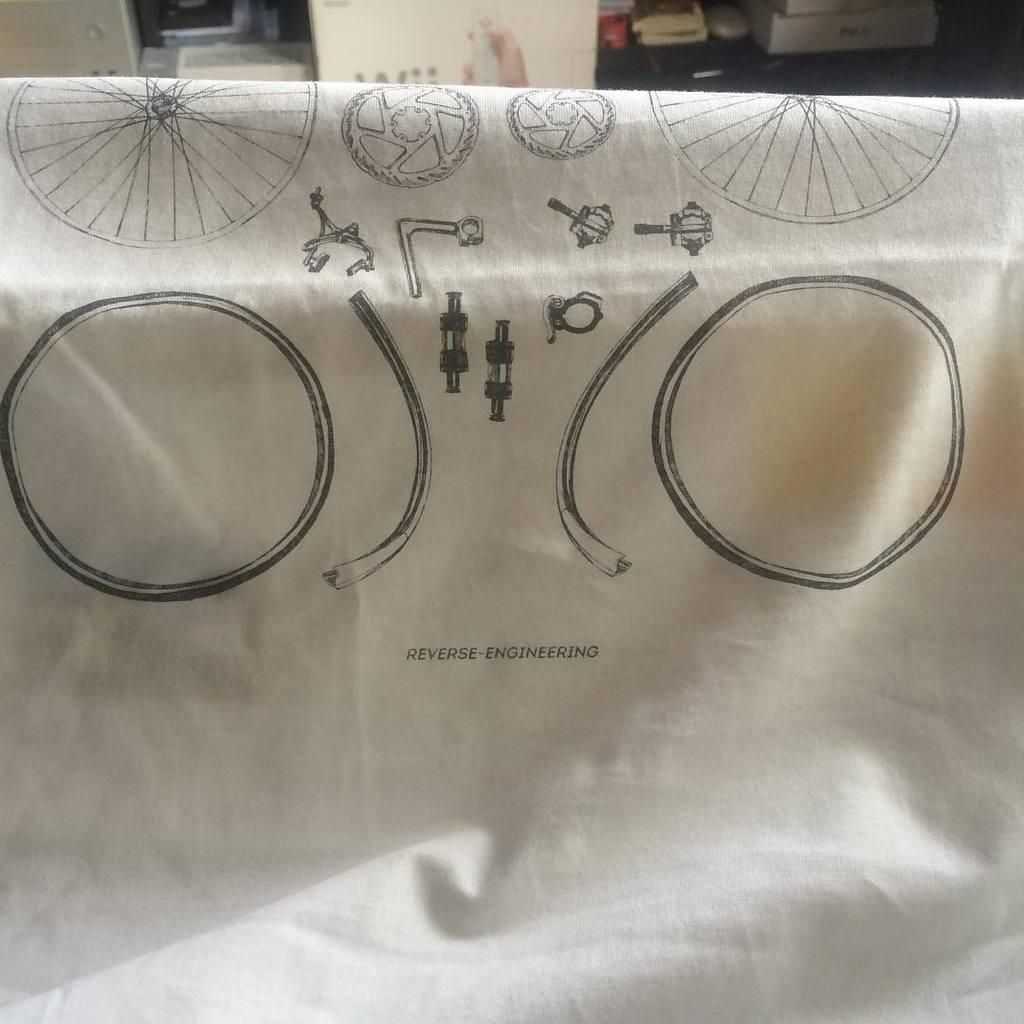What is the main subject of the image? There is a painting on a cloth in the image. Where is the painting located in the image? The painting is in the middle of the image. What can be seen in the background of the image? There is a wall and other objects visible in the background of the image. Can you see the moon in the image? No, the moon is not present in the image. Is there a spy visible in the image? No, there is no spy present in the image. 